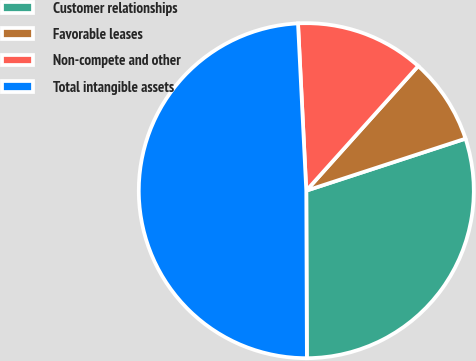Convert chart. <chart><loc_0><loc_0><loc_500><loc_500><pie_chart><fcel>Customer relationships<fcel>Favorable leases<fcel>Non-compete and other<fcel>Total intangible assets<nl><fcel>29.97%<fcel>8.33%<fcel>12.43%<fcel>49.27%<nl></chart> 